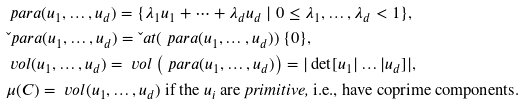<formula> <loc_0><loc_0><loc_500><loc_500>& \ p a r a ( u _ { 1 } , \dots , u _ { d } ) = \{ \lambda _ { 1 } u _ { 1 } + \cdots + \lambda _ { d } u _ { d } \ | \ 0 \leq \lambda _ { 1 } , \dots , \lambda _ { d } < 1 \} , \\ & \L p a r a ( u _ { 1 } , \dots , u _ { d } ) = \L a t ( \ p a r a ( u _ { 1 } , \dots , u _ { d } ) ) \ \{ 0 \} , \\ & \ v o l ( u _ { 1 } , \dots , u _ { d } ) = \ v o l \left ( \ p a r a ( u _ { 1 } , \dots , u _ { d } ) \right ) = | \det [ u _ { 1 } | \dots | u _ { d } ] | , \\ & \mu ( C ) = \ v o l ( u _ { 1 } , \dots , u _ { d } ) \ \text {if the} \ u _ { i } \ \text {are \emph{primitive,} i.e., have coprime components} .</formula> 